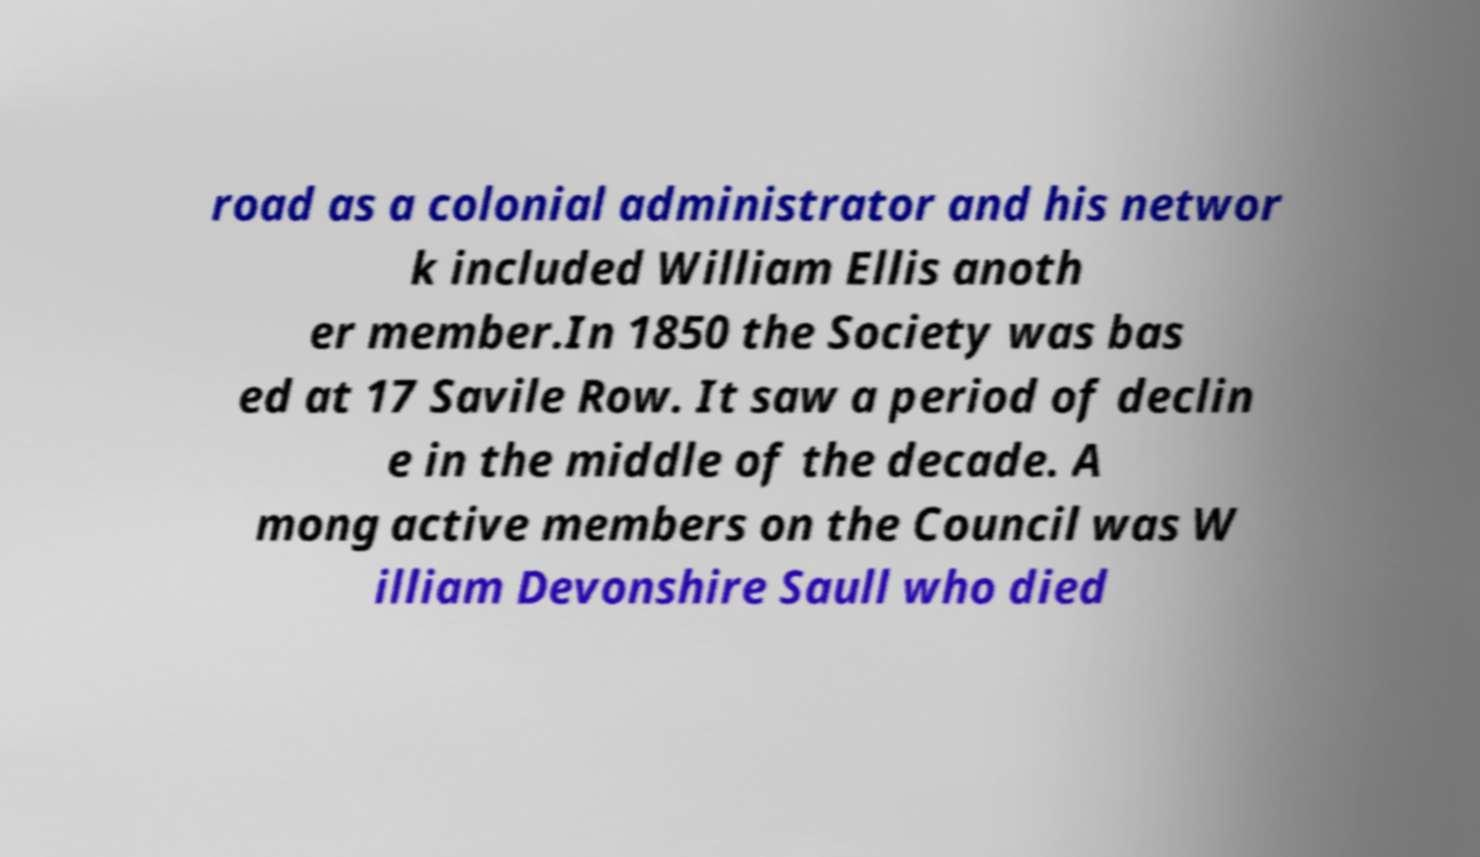What messages or text are displayed in this image? I need them in a readable, typed format. road as a colonial administrator and his networ k included William Ellis anoth er member.In 1850 the Society was bas ed at 17 Savile Row. It saw a period of declin e in the middle of the decade. A mong active members on the Council was W illiam Devonshire Saull who died 